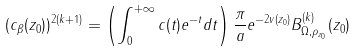Convert formula to latex. <formula><loc_0><loc_0><loc_500><loc_500>( c _ { \beta } ( z _ { 0 } ) ) ^ { 2 ( k + 1 ) } = \left ( \int _ { 0 } ^ { + \infty } c ( t ) e ^ { - t } d t \right ) \frac { \pi } { a } e ^ { - 2 v ( z _ { 0 } ) } B _ { \Omega , \rho _ { z _ { 0 } } } ^ { ( k ) } ( z _ { 0 } )</formula> 